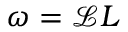Convert formula to latex. <formula><loc_0><loc_0><loc_500><loc_500>\omega = \mathcal { L } L</formula> 